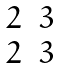<formula> <loc_0><loc_0><loc_500><loc_500>\begin{matrix} 2 & 3 \\ 2 & 3 \end{matrix}</formula> 